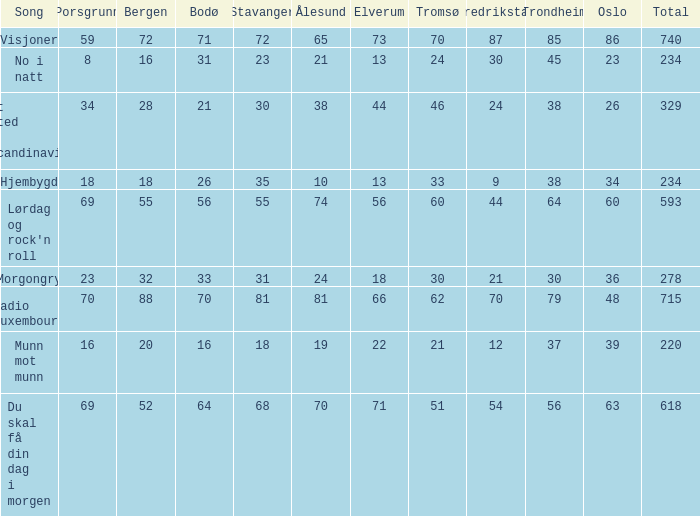What is the minimum sum? 220.0. 